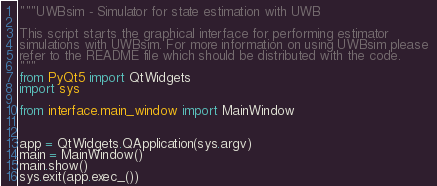<code> <loc_0><loc_0><loc_500><loc_500><_Python_>"""UWBsim - Simulator for state estimation with UWB

This script starts the graphical interface for performing estimator 
simulations with UWBsim. For more information on using UWBsim please 
refer to the README file which should be distributed with the code.
"""
from PyQt5 import QtWidgets
import sys

from interface.main_window import MainWindow


app = QtWidgets.QApplication(sys.argv)
main = MainWindow()
main.show()
sys.exit(app.exec_())</code> 